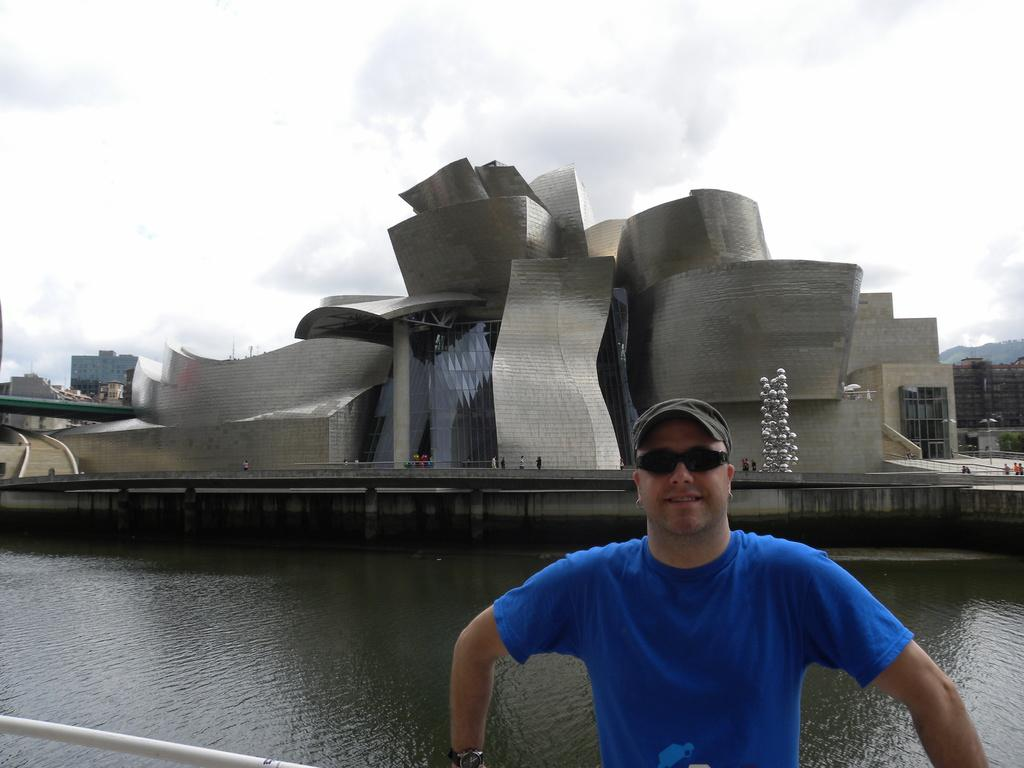Who is present in the image? There is a man in the image. What is the man wearing? The man is wearing a blue T-shirt. What can be seen in the background of the image? There is a building in the background of the image. What is visible at the bottom of the image? There is water visible at the bottom of the image. What is visible at the top of the image? There are clouds in the sky at the top of the image. What type of bulb is being used to gain knowledge and make a discovery in the image? There is no bulb present in the image, nor is there any indication of gaining knowledge or making a discovery. 